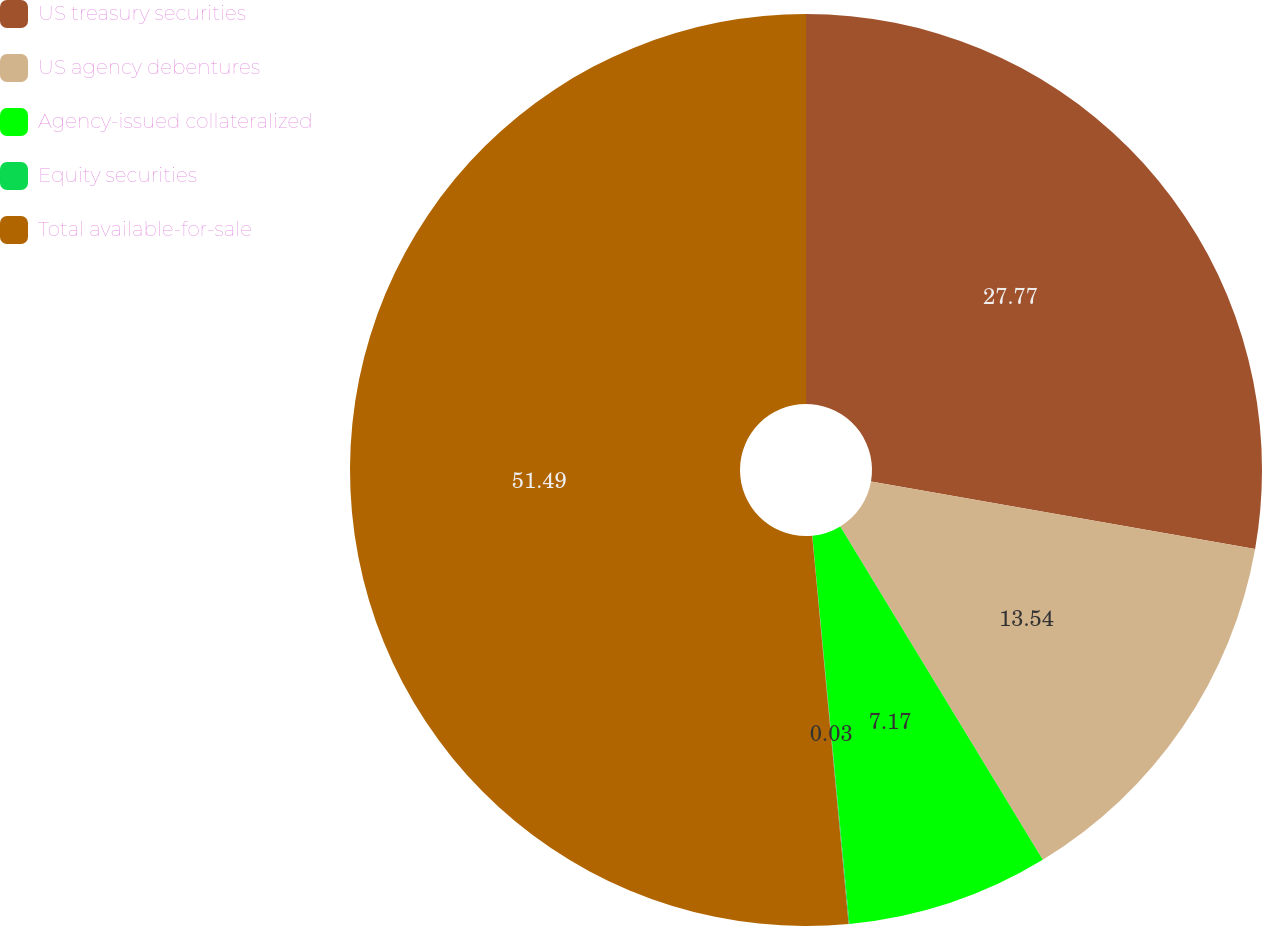<chart> <loc_0><loc_0><loc_500><loc_500><pie_chart><fcel>US treasury securities<fcel>US agency debentures<fcel>Agency-issued collateralized<fcel>Equity securities<fcel>Total available-for-sale<nl><fcel>27.77%<fcel>13.54%<fcel>7.17%<fcel>0.03%<fcel>51.49%<nl></chart> 